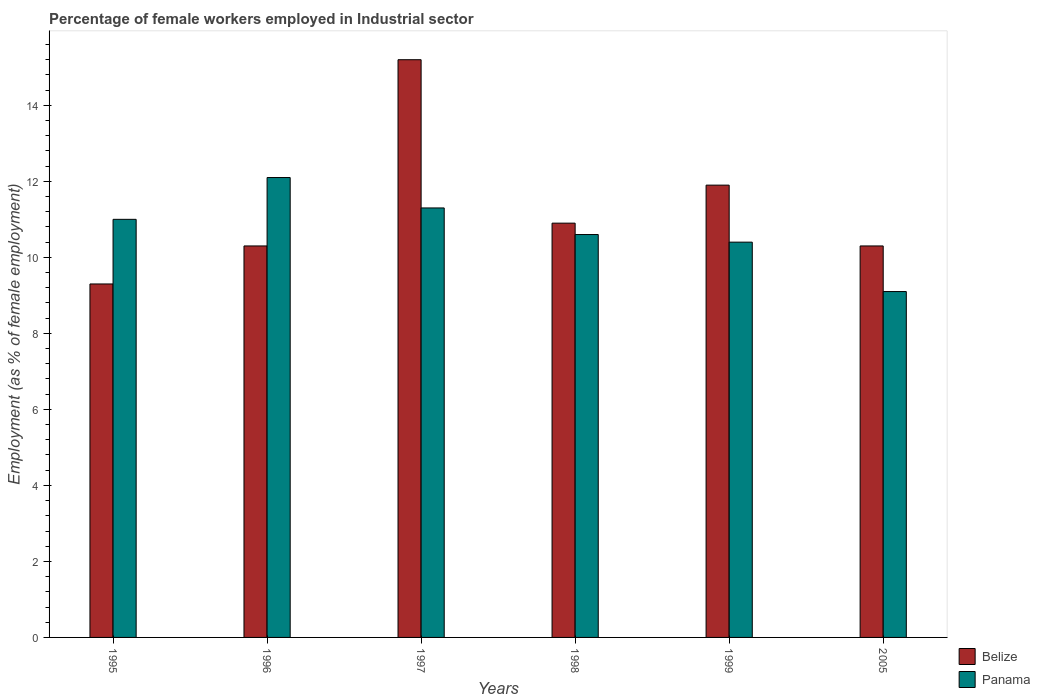Are the number of bars on each tick of the X-axis equal?
Your answer should be very brief. Yes. How many bars are there on the 2nd tick from the right?
Offer a terse response. 2. In how many cases, is the number of bars for a given year not equal to the number of legend labels?
Your answer should be very brief. 0. What is the percentage of females employed in Industrial sector in Belize in 2005?
Offer a terse response. 10.3. Across all years, what is the maximum percentage of females employed in Industrial sector in Panama?
Give a very brief answer. 12.1. Across all years, what is the minimum percentage of females employed in Industrial sector in Belize?
Your answer should be very brief. 9.3. What is the total percentage of females employed in Industrial sector in Belize in the graph?
Your answer should be very brief. 67.9. What is the difference between the percentage of females employed in Industrial sector in Belize in 1995 and that in 2005?
Offer a terse response. -1. What is the difference between the percentage of females employed in Industrial sector in Panama in 1997 and the percentage of females employed in Industrial sector in Belize in 1996?
Give a very brief answer. 1. What is the average percentage of females employed in Industrial sector in Panama per year?
Your answer should be compact. 10.75. In the year 1999, what is the difference between the percentage of females employed in Industrial sector in Belize and percentage of females employed in Industrial sector in Panama?
Your response must be concise. 1.5. In how many years, is the percentage of females employed in Industrial sector in Belize greater than 8 %?
Make the answer very short. 6. What is the ratio of the percentage of females employed in Industrial sector in Panama in 1996 to that in 1998?
Make the answer very short. 1.14. Is the percentage of females employed in Industrial sector in Belize in 1996 less than that in 1999?
Provide a short and direct response. Yes. What is the difference between the highest and the second highest percentage of females employed in Industrial sector in Panama?
Your answer should be very brief. 0.8. What is the difference between the highest and the lowest percentage of females employed in Industrial sector in Panama?
Ensure brevity in your answer.  3. What does the 2nd bar from the left in 1998 represents?
Offer a very short reply. Panama. What does the 1st bar from the right in 1997 represents?
Make the answer very short. Panama. Are all the bars in the graph horizontal?
Keep it short and to the point. No. Does the graph contain any zero values?
Your response must be concise. No. Does the graph contain grids?
Keep it short and to the point. No. How many legend labels are there?
Provide a succinct answer. 2. How are the legend labels stacked?
Your response must be concise. Vertical. What is the title of the graph?
Your response must be concise. Percentage of female workers employed in Industrial sector. What is the label or title of the Y-axis?
Offer a terse response. Employment (as % of female employment). What is the Employment (as % of female employment) of Belize in 1995?
Your answer should be compact. 9.3. What is the Employment (as % of female employment) in Belize in 1996?
Offer a very short reply. 10.3. What is the Employment (as % of female employment) of Panama in 1996?
Provide a succinct answer. 12.1. What is the Employment (as % of female employment) of Belize in 1997?
Your answer should be very brief. 15.2. What is the Employment (as % of female employment) in Panama in 1997?
Make the answer very short. 11.3. What is the Employment (as % of female employment) in Belize in 1998?
Your answer should be very brief. 10.9. What is the Employment (as % of female employment) of Panama in 1998?
Your response must be concise. 10.6. What is the Employment (as % of female employment) in Belize in 1999?
Your answer should be compact. 11.9. What is the Employment (as % of female employment) in Panama in 1999?
Provide a short and direct response. 10.4. What is the Employment (as % of female employment) in Belize in 2005?
Offer a terse response. 10.3. What is the Employment (as % of female employment) in Panama in 2005?
Provide a succinct answer. 9.1. Across all years, what is the maximum Employment (as % of female employment) of Belize?
Your answer should be compact. 15.2. Across all years, what is the maximum Employment (as % of female employment) of Panama?
Keep it short and to the point. 12.1. Across all years, what is the minimum Employment (as % of female employment) of Belize?
Your answer should be very brief. 9.3. Across all years, what is the minimum Employment (as % of female employment) of Panama?
Give a very brief answer. 9.1. What is the total Employment (as % of female employment) of Belize in the graph?
Make the answer very short. 67.9. What is the total Employment (as % of female employment) of Panama in the graph?
Your answer should be compact. 64.5. What is the difference between the Employment (as % of female employment) of Belize in 1995 and that in 1997?
Give a very brief answer. -5.9. What is the difference between the Employment (as % of female employment) in Panama in 1995 and that in 1997?
Provide a short and direct response. -0.3. What is the difference between the Employment (as % of female employment) in Belize in 1995 and that in 1998?
Keep it short and to the point. -1.6. What is the difference between the Employment (as % of female employment) of Belize in 1995 and that in 1999?
Your answer should be compact. -2.6. What is the difference between the Employment (as % of female employment) of Panama in 1995 and that in 1999?
Give a very brief answer. 0.6. What is the difference between the Employment (as % of female employment) of Panama in 1996 and that in 1998?
Provide a short and direct response. 1.5. What is the difference between the Employment (as % of female employment) of Belize in 1996 and that in 1999?
Provide a short and direct response. -1.6. What is the difference between the Employment (as % of female employment) of Panama in 1996 and that in 1999?
Provide a short and direct response. 1.7. What is the difference between the Employment (as % of female employment) in Belize in 1996 and that in 2005?
Offer a very short reply. 0. What is the difference between the Employment (as % of female employment) of Panama in 1997 and that in 1998?
Offer a very short reply. 0.7. What is the difference between the Employment (as % of female employment) of Panama in 1997 and that in 1999?
Ensure brevity in your answer.  0.9. What is the difference between the Employment (as % of female employment) of Belize in 1997 and that in 2005?
Ensure brevity in your answer.  4.9. What is the difference between the Employment (as % of female employment) in Belize in 1998 and that in 1999?
Provide a succinct answer. -1. What is the difference between the Employment (as % of female employment) in Belize in 1998 and that in 2005?
Give a very brief answer. 0.6. What is the difference between the Employment (as % of female employment) of Belize in 1996 and the Employment (as % of female employment) of Panama in 1997?
Keep it short and to the point. -1. What is the difference between the Employment (as % of female employment) of Belize in 1996 and the Employment (as % of female employment) of Panama in 2005?
Your response must be concise. 1.2. What is the difference between the Employment (as % of female employment) of Belize in 1997 and the Employment (as % of female employment) of Panama in 1998?
Provide a short and direct response. 4.6. What is the difference between the Employment (as % of female employment) of Belize in 1997 and the Employment (as % of female employment) of Panama in 1999?
Keep it short and to the point. 4.8. What is the difference between the Employment (as % of female employment) in Belize in 1999 and the Employment (as % of female employment) in Panama in 2005?
Give a very brief answer. 2.8. What is the average Employment (as % of female employment) in Belize per year?
Give a very brief answer. 11.32. What is the average Employment (as % of female employment) of Panama per year?
Your answer should be compact. 10.75. In the year 1996, what is the difference between the Employment (as % of female employment) of Belize and Employment (as % of female employment) of Panama?
Keep it short and to the point. -1.8. In the year 1997, what is the difference between the Employment (as % of female employment) of Belize and Employment (as % of female employment) of Panama?
Your answer should be very brief. 3.9. In the year 1999, what is the difference between the Employment (as % of female employment) of Belize and Employment (as % of female employment) of Panama?
Your response must be concise. 1.5. What is the ratio of the Employment (as % of female employment) of Belize in 1995 to that in 1996?
Offer a terse response. 0.9. What is the ratio of the Employment (as % of female employment) in Panama in 1995 to that in 1996?
Offer a very short reply. 0.91. What is the ratio of the Employment (as % of female employment) in Belize in 1995 to that in 1997?
Your answer should be compact. 0.61. What is the ratio of the Employment (as % of female employment) of Panama in 1995 to that in 1997?
Your answer should be compact. 0.97. What is the ratio of the Employment (as % of female employment) in Belize in 1995 to that in 1998?
Offer a very short reply. 0.85. What is the ratio of the Employment (as % of female employment) of Panama in 1995 to that in 1998?
Keep it short and to the point. 1.04. What is the ratio of the Employment (as % of female employment) in Belize in 1995 to that in 1999?
Keep it short and to the point. 0.78. What is the ratio of the Employment (as % of female employment) in Panama in 1995 to that in 1999?
Offer a terse response. 1.06. What is the ratio of the Employment (as % of female employment) of Belize in 1995 to that in 2005?
Provide a succinct answer. 0.9. What is the ratio of the Employment (as % of female employment) of Panama in 1995 to that in 2005?
Offer a terse response. 1.21. What is the ratio of the Employment (as % of female employment) of Belize in 1996 to that in 1997?
Your response must be concise. 0.68. What is the ratio of the Employment (as % of female employment) of Panama in 1996 to that in 1997?
Your answer should be very brief. 1.07. What is the ratio of the Employment (as % of female employment) of Belize in 1996 to that in 1998?
Keep it short and to the point. 0.94. What is the ratio of the Employment (as % of female employment) in Panama in 1996 to that in 1998?
Offer a very short reply. 1.14. What is the ratio of the Employment (as % of female employment) of Belize in 1996 to that in 1999?
Make the answer very short. 0.87. What is the ratio of the Employment (as % of female employment) in Panama in 1996 to that in 1999?
Give a very brief answer. 1.16. What is the ratio of the Employment (as % of female employment) of Panama in 1996 to that in 2005?
Make the answer very short. 1.33. What is the ratio of the Employment (as % of female employment) in Belize in 1997 to that in 1998?
Offer a terse response. 1.39. What is the ratio of the Employment (as % of female employment) of Panama in 1997 to that in 1998?
Make the answer very short. 1.07. What is the ratio of the Employment (as % of female employment) in Belize in 1997 to that in 1999?
Your answer should be very brief. 1.28. What is the ratio of the Employment (as % of female employment) in Panama in 1997 to that in 1999?
Ensure brevity in your answer.  1.09. What is the ratio of the Employment (as % of female employment) in Belize in 1997 to that in 2005?
Provide a short and direct response. 1.48. What is the ratio of the Employment (as % of female employment) in Panama in 1997 to that in 2005?
Your answer should be compact. 1.24. What is the ratio of the Employment (as % of female employment) in Belize in 1998 to that in 1999?
Ensure brevity in your answer.  0.92. What is the ratio of the Employment (as % of female employment) in Panama in 1998 to that in 1999?
Provide a short and direct response. 1.02. What is the ratio of the Employment (as % of female employment) of Belize in 1998 to that in 2005?
Your answer should be compact. 1.06. What is the ratio of the Employment (as % of female employment) in Panama in 1998 to that in 2005?
Make the answer very short. 1.16. What is the ratio of the Employment (as % of female employment) in Belize in 1999 to that in 2005?
Make the answer very short. 1.16. What is the ratio of the Employment (as % of female employment) of Panama in 1999 to that in 2005?
Offer a very short reply. 1.14. What is the difference between the highest and the second highest Employment (as % of female employment) of Belize?
Offer a terse response. 3.3. What is the difference between the highest and the lowest Employment (as % of female employment) of Belize?
Provide a short and direct response. 5.9. 